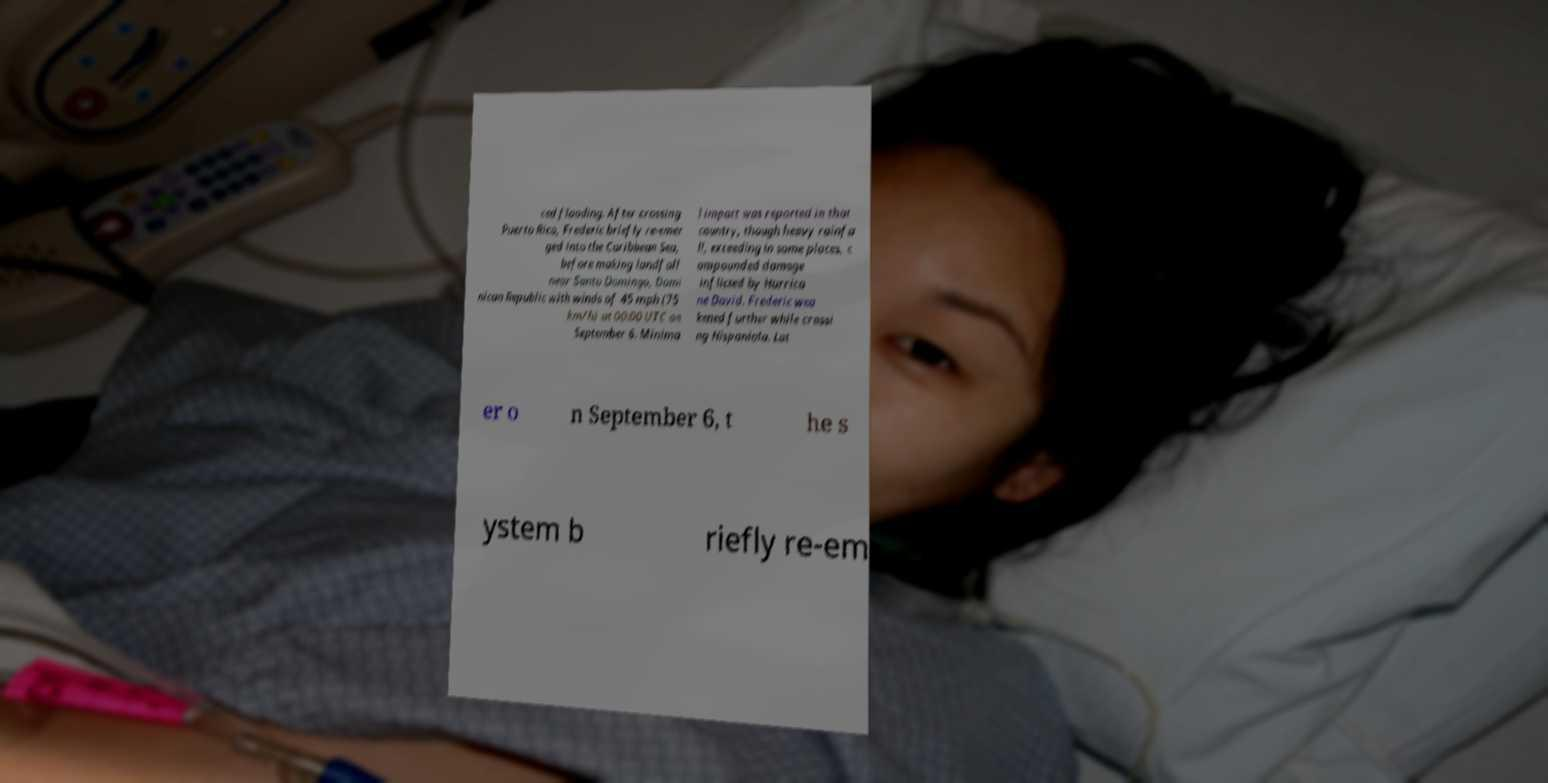Can you accurately transcribe the text from the provided image for me? ced flooding. After crossing Puerto Rico, Frederic briefly re-emer ged into the Caribbean Sea, before making landfall near Santo Domingo, Domi nican Republic with winds of 45 mph (75 km/h) at 00:00 UTC on September 6. Minima l impact was reported in that country, though heavy rainfa ll, exceeding in some places, c ompounded damage inflicted by Hurrica ne David. Frederic wea kened further while crossi ng Hispaniola. Lat er o n September 6, t he s ystem b riefly re-em 